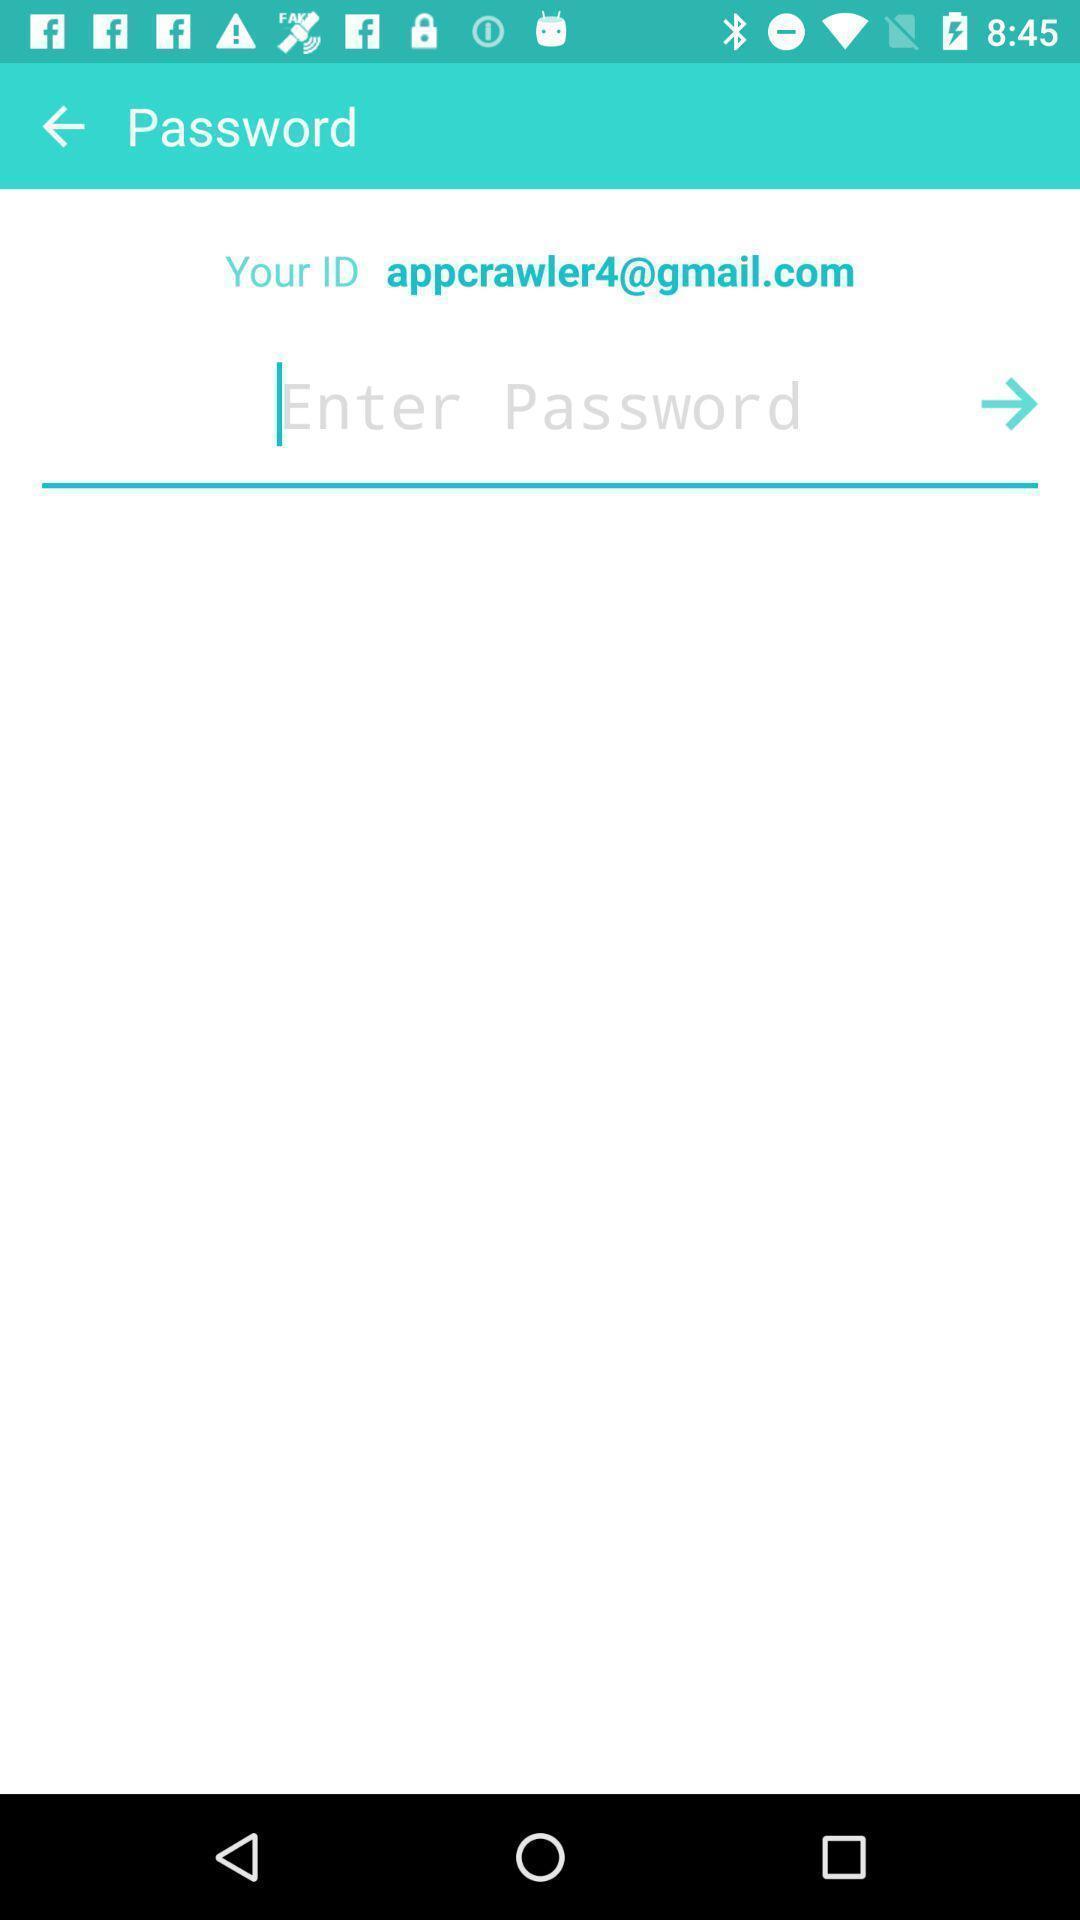Describe the content in this image. Password page of an online entertaining app. 